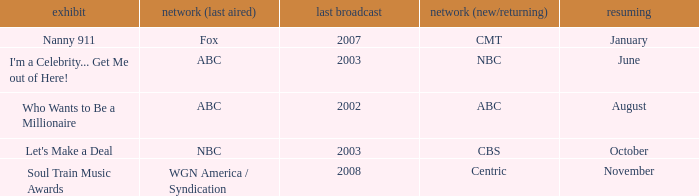What show was played on ABC laster after 2002? I'm a Celebrity... Get Me out of Here!. 